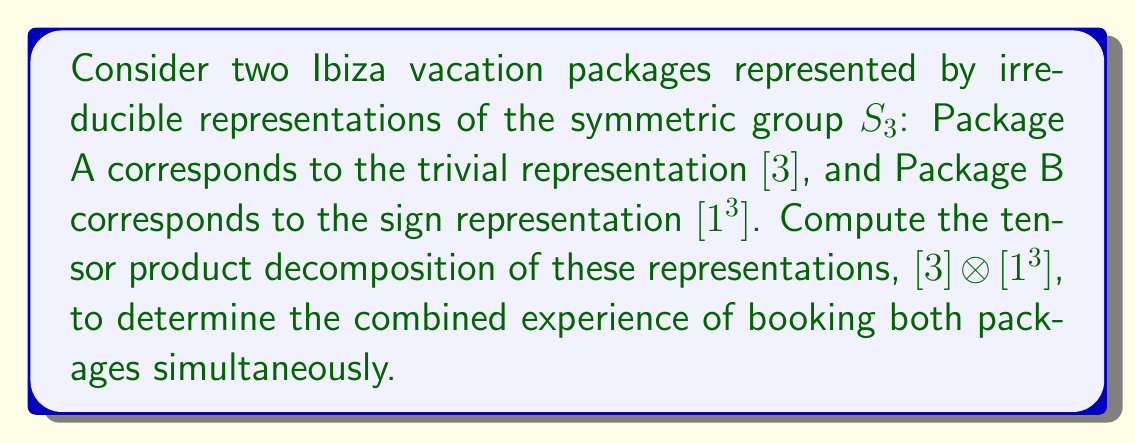Can you answer this question? To compute the tensor product decomposition, we'll follow these steps:

1) Recall that $S_3$ has three irreducible representations: $[3]$ (trivial), $[2,1]$ (standard), and $[1^3]$ (sign).

2) The tensor product of the trivial representation with any representation $V$ is always $V$ itself. This is because:

   $$[3] \otimes V \cong V$$

3) In this case, we're computing $[3] \otimes [1^3]$. Applying the rule from step 2:

   $$[3] \otimes [1^3] \cong [1^3]$$

4) This result means that the combined experience of booking both packages simultaneously is equivalent to just booking Package B (the sign representation).

5) Intuitively, this makes sense because the trivial representation $[3]$ doesn't add any new "flavor" to the experience, while the sign representation $[1^3]$ determines the overall character of the combined package.
Answer: $[3] \otimes [1^3] \cong [1^3]$ 